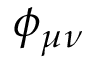Convert formula to latex. <formula><loc_0><loc_0><loc_500><loc_500>\phi _ { \mu \nu }</formula> 